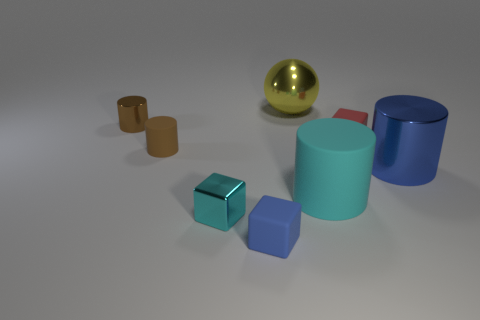Subtract all tiny matte blocks. How many blocks are left? 1 Add 2 brown matte things. How many objects exist? 10 Subtract 2 cylinders. How many cylinders are left? 2 Subtract all blue cubes. How many cubes are left? 2 Add 4 large green metallic balls. How many large green metallic balls exist? 4 Subtract 0 brown cubes. How many objects are left? 8 Subtract all blocks. How many objects are left? 5 Subtract all purple blocks. Subtract all brown cylinders. How many blocks are left? 3 Subtract all purple spheres. How many brown cylinders are left? 2 Subtract all cyan metal balls. Subtract all cyan metallic things. How many objects are left? 7 